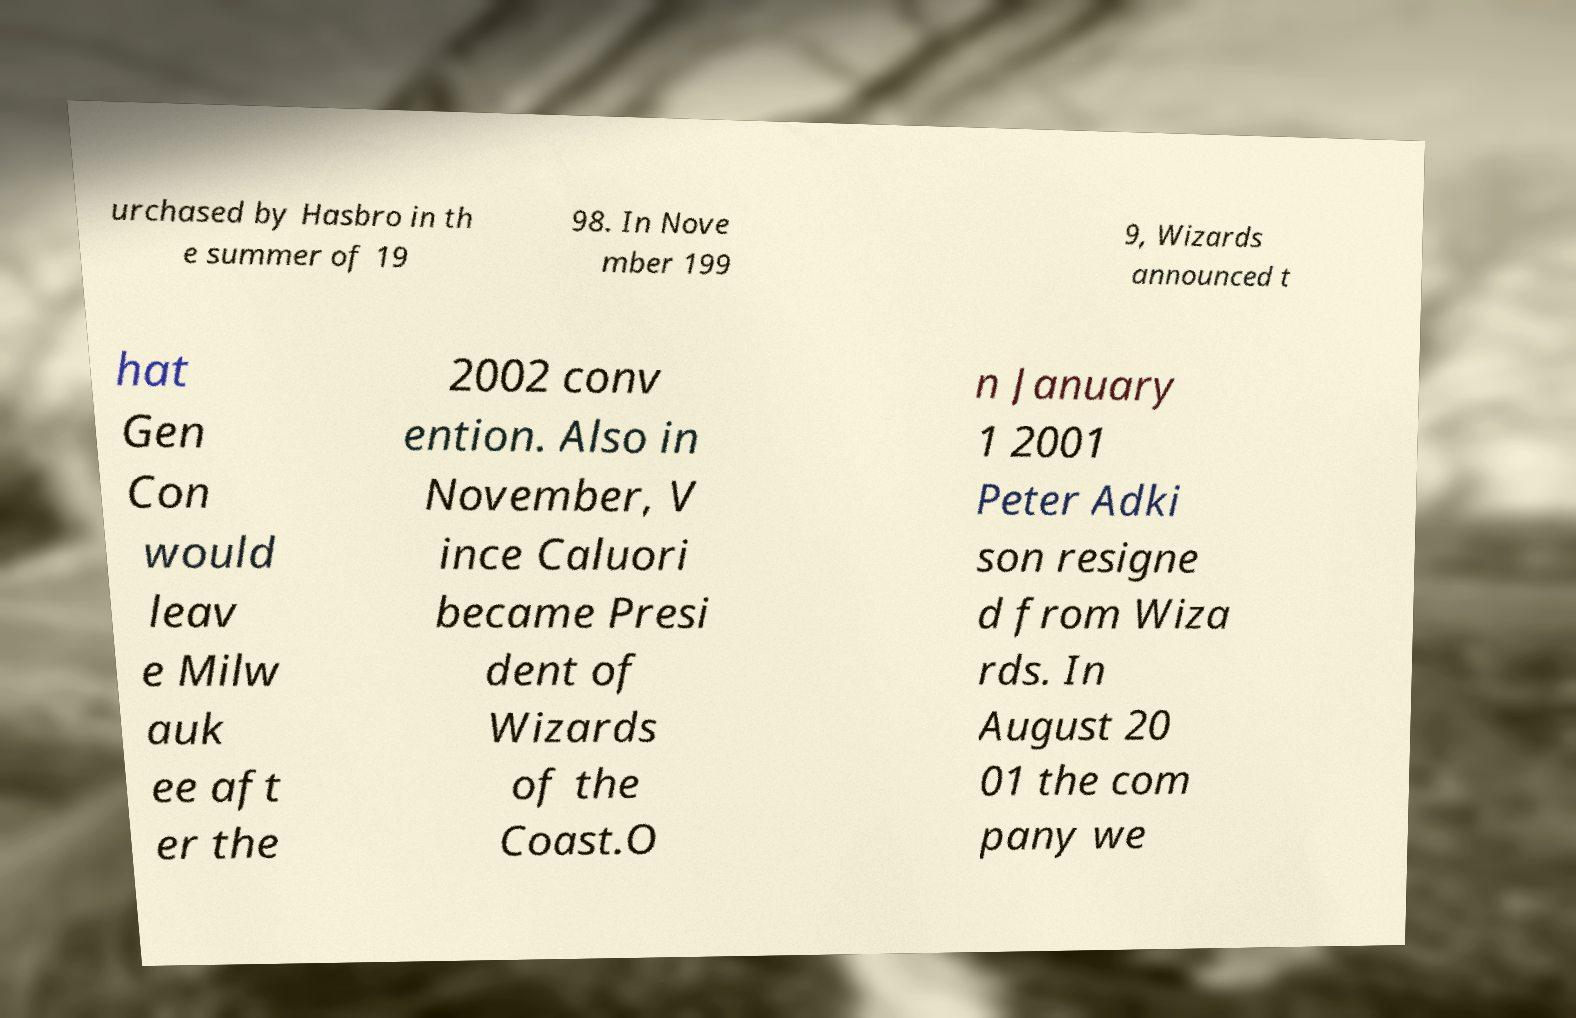Please read and relay the text visible in this image. What does it say? urchased by Hasbro in th e summer of 19 98. In Nove mber 199 9, Wizards announced t hat Gen Con would leav e Milw auk ee aft er the 2002 conv ention. Also in November, V ince Caluori became Presi dent of Wizards of the Coast.O n January 1 2001 Peter Adki son resigne d from Wiza rds. In August 20 01 the com pany we 